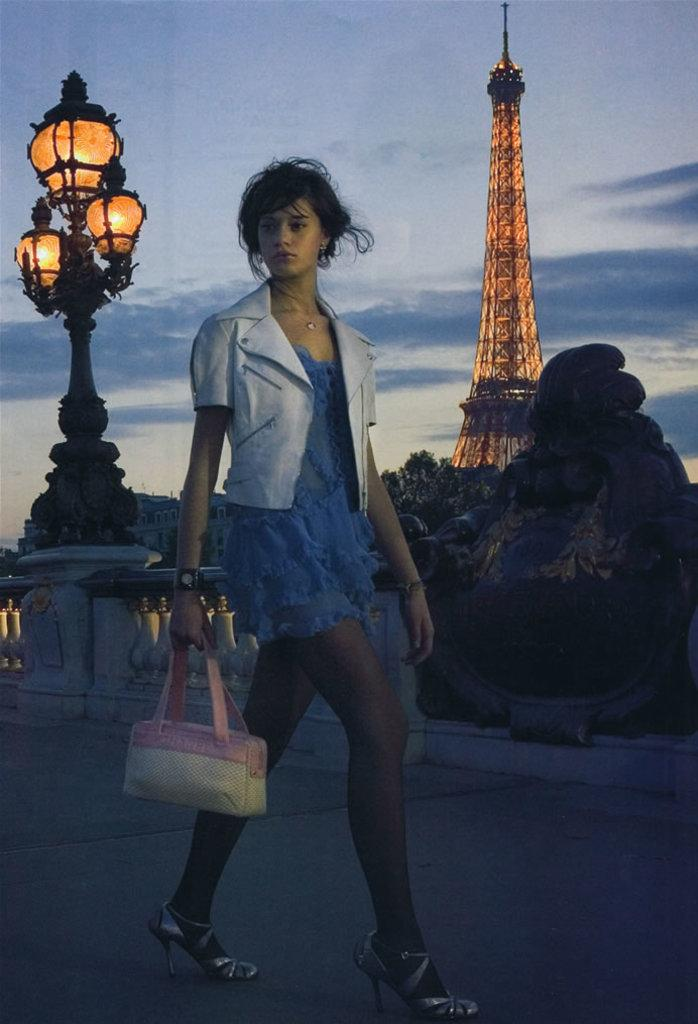Who is present in the image? There is a woman in the image. What is the woman holding in her hand? The woman is holding a bag in her hand. What can be seen in the image that provides illumination? There is a light in the image. What type of structure is visible in the image? There is a building in the image. What famous landmark is present in the image? The Eiffel Tower is present in the image. How would you describe the weather based on the image? The sky is cloudy in the image. What type of pipe is visible in the image? There is no pipe present in the image. 